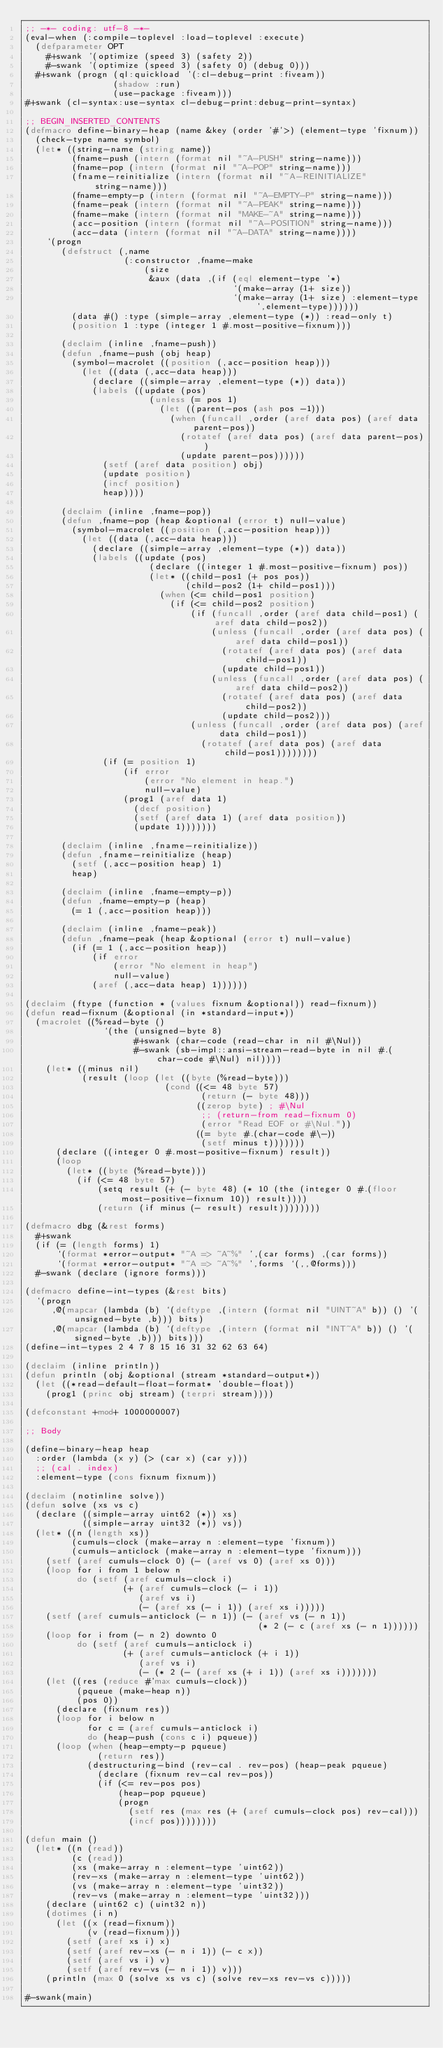Convert code to text. <code><loc_0><loc_0><loc_500><loc_500><_Lisp_>;; -*- coding: utf-8 -*-
(eval-when (:compile-toplevel :load-toplevel :execute)
  (defparameter OPT
    #+swank '(optimize (speed 3) (safety 2))
    #-swank '(optimize (speed 3) (safety 0) (debug 0)))
  #+swank (progn (ql:quickload '(:cl-debug-print :fiveam))
                 (shadow :run)
                 (use-package :fiveam)))
#+swank (cl-syntax:use-syntax cl-debug-print:debug-print-syntax)

;; BEGIN_INSERTED_CONTENTS
(defmacro define-binary-heap (name &key (order '#'>) (element-type 'fixnum))
  (check-type name symbol)
  (let* ((string-name (string name))
         (fname-push (intern (format nil "~A-PUSH" string-name)))
         (fname-pop (intern (format nil "~A-POP" string-name)))
         (fname-reinitialize (intern (format nil "~A-REINITIALIZE" string-name)))
         (fname-empty-p (intern (format nil "~A-EMPTY-P" string-name)))
         (fname-peak (intern (format nil "~A-PEAK" string-name)))
         (fname-make (intern (format nil "MAKE-~A" string-name)))
         (acc-position (intern (format nil "~A-POSITION" string-name)))
         (acc-data (intern (format nil "~A-DATA" string-name))))
    `(progn
       (defstruct (,name
                   (:constructor ,fname-make
                       (size
                        &aux (data ,(if (eql element-type '*)
                                        `(make-array (1+ size))
                                        `(make-array (1+ size) :element-type ',element-type))))))
         (data #() :type (simple-array ,element-type (*)) :read-only t)
         (position 1 :type (integer 1 #.most-positive-fixnum)))

       (declaim (inline ,fname-push))
       (defun ,fname-push (obj heap)
         (symbol-macrolet ((position (,acc-position heap)))
           (let ((data (,acc-data heap)))
             (declare ((simple-array ,element-type (*)) data))
             (labels ((update (pos)
                        (unless (= pos 1)
                          (let ((parent-pos (ash pos -1)))
                            (when (funcall ,order (aref data pos) (aref data parent-pos))
                              (rotatef (aref data pos) (aref data parent-pos))
                              (update parent-pos))))))
               (setf (aref data position) obj)
               (update position)
               (incf position)
               heap))))

       (declaim (inline ,fname-pop))
       (defun ,fname-pop (heap &optional (error t) null-value)
         (symbol-macrolet ((position (,acc-position heap)))
           (let ((data (,acc-data heap)))
             (declare ((simple-array ,element-type (*)) data))
             (labels ((update (pos)
                        (declare ((integer 1 #.most-positive-fixnum) pos))
                        (let* ((child-pos1 (+ pos pos))
                               (child-pos2 (1+ child-pos1)))
                          (when (<= child-pos1 position)
                            (if (<= child-pos2 position)
                                (if (funcall ,order (aref data child-pos1) (aref data child-pos2))
                                    (unless (funcall ,order (aref data pos) (aref data child-pos1))
                                      (rotatef (aref data pos) (aref data child-pos1))
                                      (update child-pos1))
                                    (unless (funcall ,order (aref data pos) (aref data child-pos2))
                                      (rotatef (aref data pos) (aref data child-pos2))
                                      (update child-pos2)))
                                (unless (funcall ,order (aref data pos) (aref data child-pos1))
                                  (rotatef (aref data pos) (aref data child-pos1))))))))
               (if (= position 1)
                   (if error
                       (error "No element in heap.")
                       null-value)
                   (prog1 (aref data 1)
                     (decf position)
                     (setf (aref data 1) (aref data position))
                     (update 1)))))))

       (declaim (inline ,fname-reinitialize))
       (defun ,fname-reinitialize (heap)
         (setf (,acc-position heap) 1)
         heap)

       (declaim (inline ,fname-empty-p))
       (defun ,fname-empty-p (heap)
         (= 1 (,acc-position heap)))

       (declaim (inline ,fname-peak))
       (defun ,fname-peak (heap &optional (error t) null-value)
         (if (= 1 (,acc-position heap))
             (if error
                 (error "No element in heap")
                 null-value)
             (aref (,acc-data heap) 1))))))

(declaim (ftype (function * (values fixnum &optional)) read-fixnum))
(defun read-fixnum (&optional (in *standard-input*))
  (macrolet ((%read-byte ()
               `(the (unsigned-byte 8)
                     #+swank (char-code (read-char in nil #\Nul))
                     #-swank (sb-impl::ansi-stream-read-byte in nil #.(char-code #\Nul) nil))))
    (let* ((minus nil)
           (result (loop (let ((byte (%read-byte)))
                           (cond ((<= 48 byte 57)
                                  (return (- byte 48)))
                                 ((zerop byte) ; #\Nul
                                  ;; (return-from read-fixnum 0)
                                  (error "Read EOF or #\Nul."))
                                 ((= byte #.(char-code #\-))
                                  (setf minus t)))))))
      (declare ((integer 0 #.most-positive-fixnum) result))
      (loop
        (let* ((byte (%read-byte)))
          (if (<= 48 byte 57)
              (setq result (+ (- byte 48) (* 10 (the (integer 0 #.(floor most-positive-fixnum 10)) result))))
              (return (if minus (- result) result))))))))

(defmacro dbg (&rest forms)
  #+swank
  (if (= (length forms) 1)
      `(format *error-output* "~A => ~A~%" ',(car forms) ,(car forms))
      `(format *error-output* "~A => ~A~%" ',forms `(,,@forms)))
  #-swank (declare (ignore forms)))

(defmacro define-int-types (&rest bits)
  `(progn
     ,@(mapcar (lambda (b) `(deftype ,(intern (format nil "UINT~A" b)) () '(unsigned-byte ,b))) bits)
     ,@(mapcar (lambda (b) `(deftype ,(intern (format nil "INT~A" b)) () '(signed-byte ,b))) bits)))
(define-int-types 2 4 7 8 15 16 31 32 62 63 64)

(declaim (inline println))
(defun println (obj &optional (stream *standard-output*))
  (let ((*read-default-float-format* 'double-float))
    (prog1 (princ obj stream) (terpri stream))))

(defconstant +mod+ 1000000007)

;; Body

(define-binary-heap heap
  :order (lambda (x y) (> (car x) (car y)))
  ;; (cal . index)
  :element-type (cons fixnum fixnum))

(declaim (notinline solve))
(defun solve (xs vs c)
  (declare ((simple-array uint62 (*)) xs)
           ((simple-array uint32 (*)) vs))
  (let* ((n (length xs))
         (cumuls-clock (make-array n :element-type 'fixnum))
         (cumuls-anticlock (make-array n :element-type 'fixnum)))
    (setf (aref cumuls-clock 0) (- (aref vs 0) (aref xs 0)))
    (loop for i from 1 below n
          do (setf (aref cumuls-clock i)
                   (+ (aref cumuls-clock (- i 1))
                      (aref vs i)
                      (- (aref xs (- i 1)) (aref xs i)))))
    (setf (aref cumuls-anticlock (- n 1)) (- (aref vs (- n 1))
                                             (* 2 (- c (aref xs (- n 1))))))
    (loop for i from (- n 2) downto 0
          do (setf (aref cumuls-anticlock i)
                   (+ (aref cumuls-anticlock (+ i 1))
                      (aref vs i)
                      (- (* 2 (- (aref xs (+ i 1)) (aref xs i)))))))
    (let ((res (reduce #'max cumuls-clock))
          (pqueue (make-heap n))
          (pos 0))
      (declare (fixnum res))
      (loop for i below n
            for c = (aref cumuls-anticlock i)
            do (heap-push (cons c i) pqueue))
      (loop (when (heap-empty-p pqueue)
              (return res))
            (destructuring-bind (rev-cal . rev-pos) (heap-peak pqueue)
              (declare (fixnum rev-cal rev-pos))
              (if (<= rev-pos pos)
                  (heap-pop pqueue)
                  (progn
                    (setf res (max res (+ (aref cumuls-clock pos) rev-cal)))
                    (incf pos))))))))

(defun main ()
  (let* ((n (read))
         (c (read))
         (xs (make-array n :element-type 'uint62))
         (rev-xs (make-array n :element-type 'uint62))
         (vs (make-array n :element-type 'uint32))
         (rev-vs (make-array n :element-type 'uint32)))
    (declare (uint62 c) (uint32 n))
    (dotimes (i n)
      (let ((x (read-fixnum))
            (v (read-fixnum)))
        (setf (aref xs i) x)
        (setf (aref rev-xs (- n i 1)) (- c x))
        (setf (aref vs i) v)
        (setf (aref rev-vs (- n i 1)) v)))
    (println (max 0 (solve xs vs c) (solve rev-xs rev-vs c)))))

#-swank(main)
</code> 